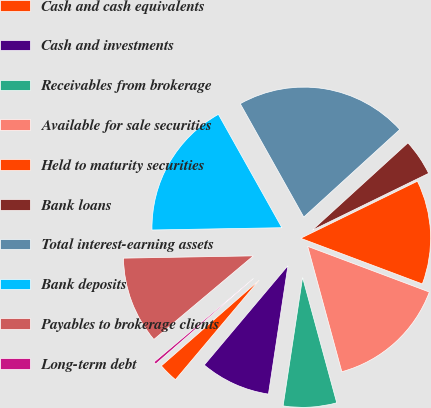<chart> <loc_0><loc_0><loc_500><loc_500><pie_chart><fcel>Cash and cash equivalents<fcel>Cash and investments<fcel>Receivables from brokerage<fcel>Available for sale securities<fcel>Held to maturity securities<fcel>Bank loans<fcel>Total interest-earning assets<fcel>Bank deposits<fcel>Payables to brokerage clients<fcel>Long-term debt<nl><fcel>2.42%<fcel>8.74%<fcel>6.63%<fcel>15.05%<fcel>12.95%<fcel>4.53%<fcel>21.36%<fcel>17.15%<fcel>10.84%<fcel>0.32%<nl></chart> 